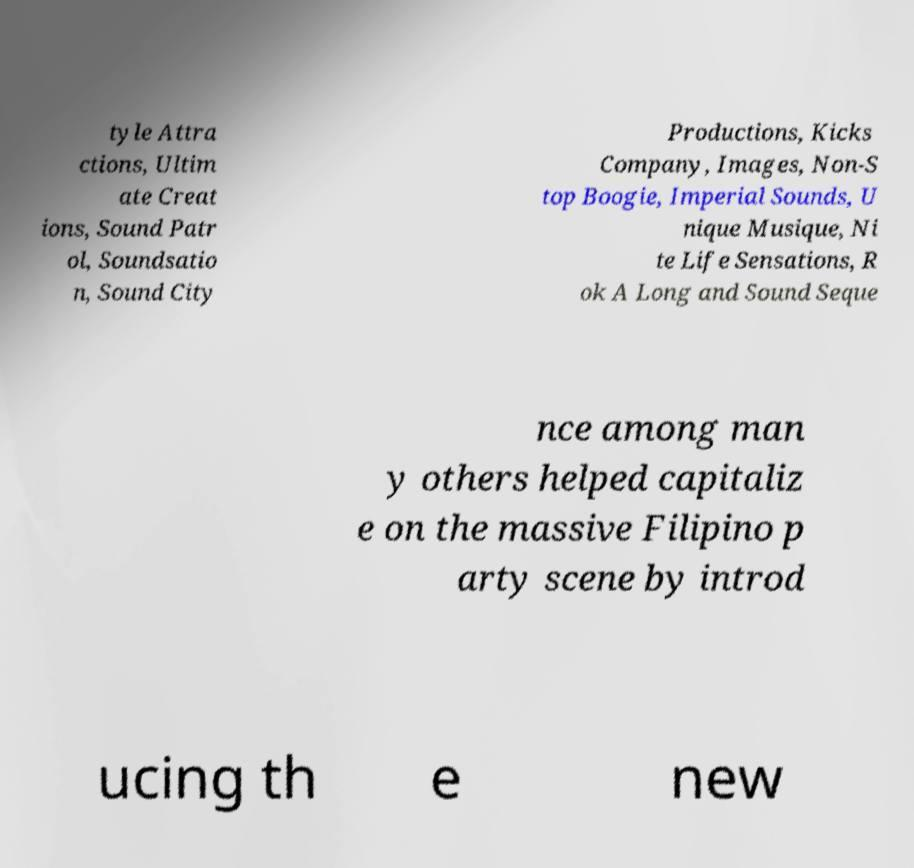I need the written content from this picture converted into text. Can you do that? tyle Attra ctions, Ultim ate Creat ions, Sound Patr ol, Soundsatio n, Sound City Productions, Kicks Company, Images, Non-S top Boogie, Imperial Sounds, U nique Musique, Ni te Life Sensations, R ok A Long and Sound Seque nce among man y others helped capitaliz e on the massive Filipino p arty scene by introd ucing th e new 